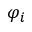Convert formula to latex. <formula><loc_0><loc_0><loc_500><loc_500>\varphi _ { i }</formula> 